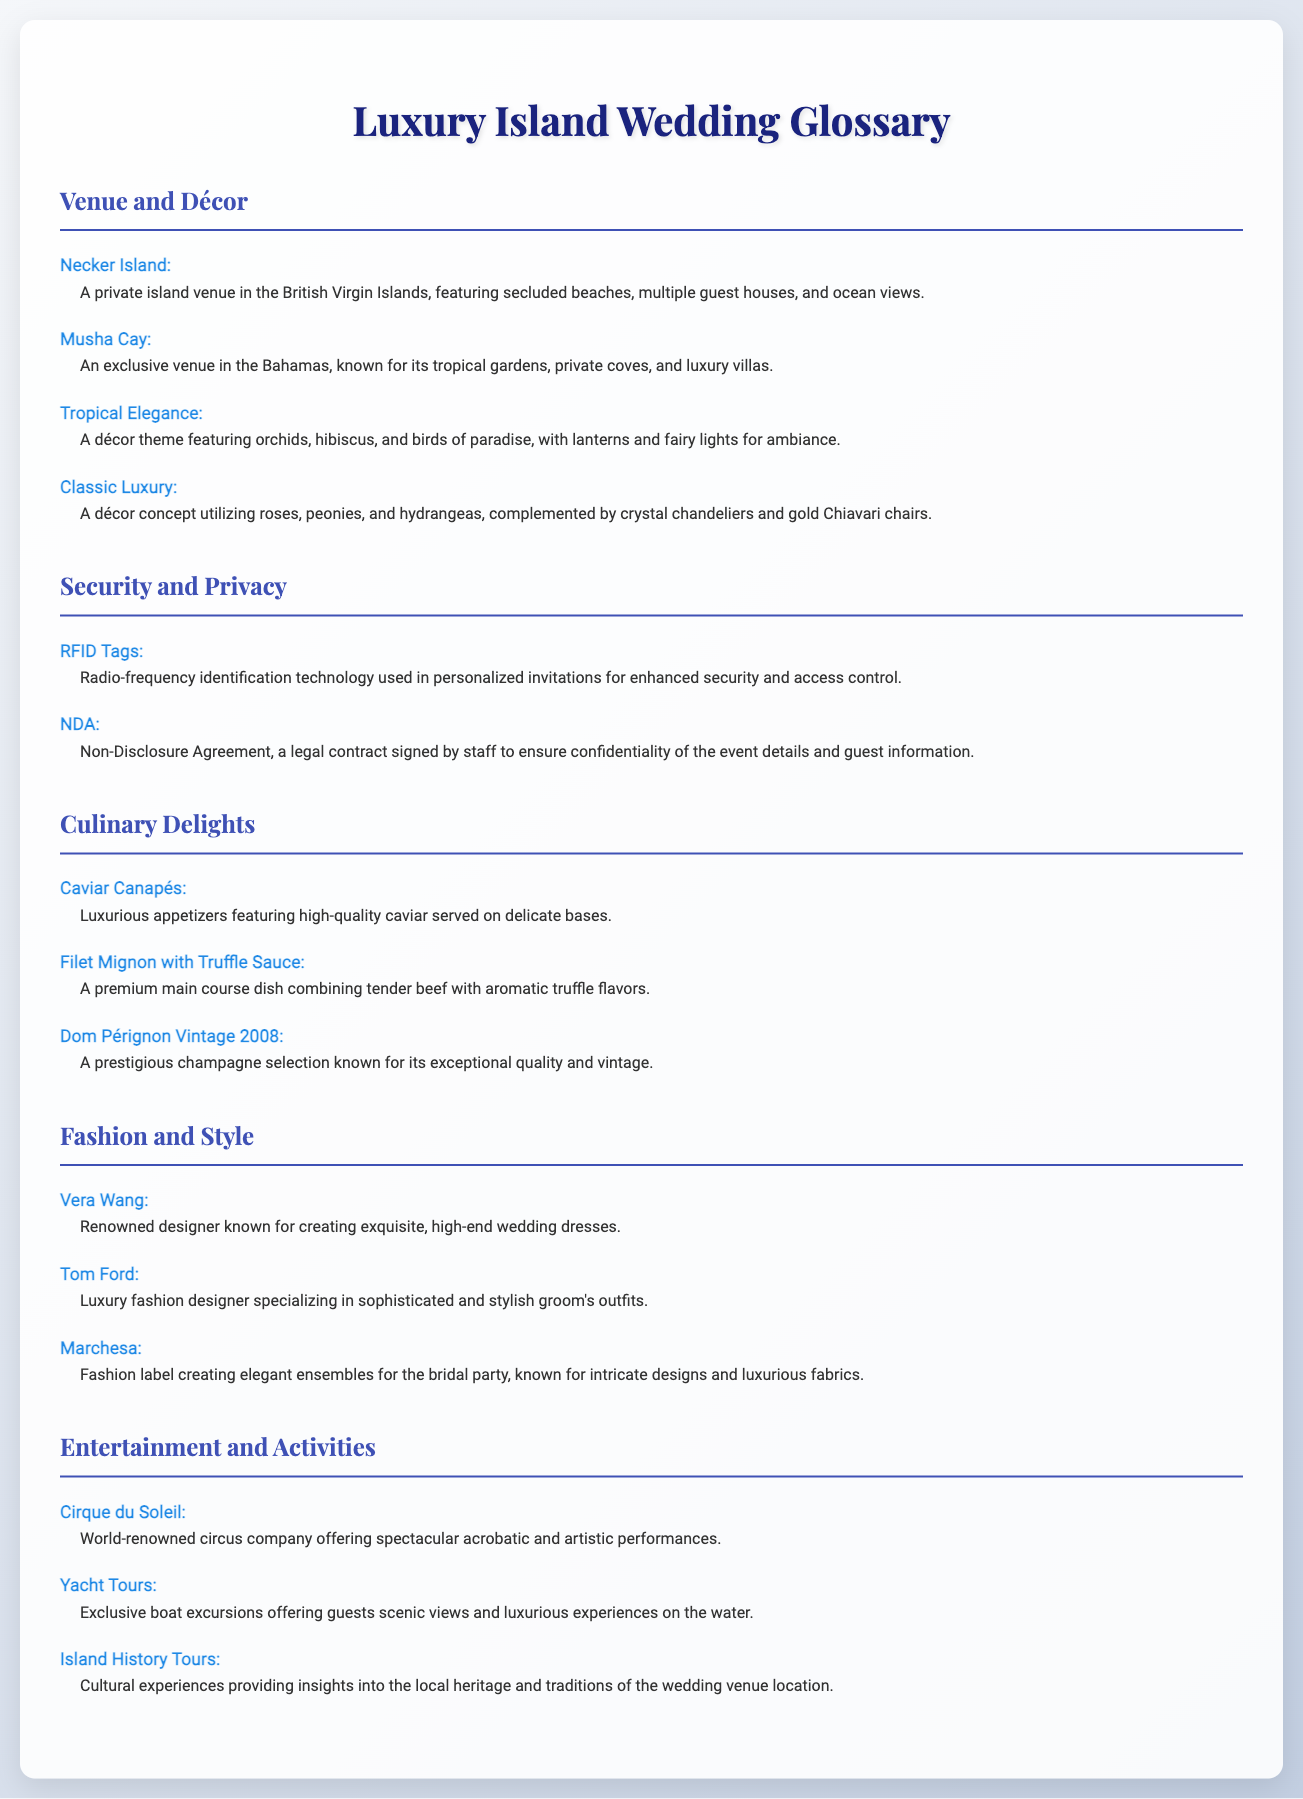What is the name of a private island venue in the British Virgin Islands? Necker Island is mentioned as a private island venue in the British Virgin Islands in the document.
Answer: Necker Island What décor theme features orchids and lanterns? The document describes the "Tropical Elegance" décor theme, which includes orchids, hibiscus, and lanterns.
Answer: Tropical Elegance Which legal contract ensures confidentiality of event details? The document states that an NDA (Non-Disclosure Agreement) is a legal contract for confidentiality.
Answer: NDA What is a luxurious appetizer mentioned in the culinary section? The document lists "Caviar Canapés" as a luxurious appetizer option.
Answer: Caviar Canapés Which designer is known for creating high-end wedding dresses? Vera Wang is identified in the document as a renowned designer for wedding dresses.
Answer: Vera Wang What is the name of the world-renowned circus company? The document mentions "Cirque du Soleil" as the name of the circus company offering performances.
Answer: Cirque du Soleil What type of tours provide insights into local heritage? The document refers to "Island History Tours" as cultural experiences offering insights into local heritage.
Answer: Island History Tours How are security measures enhanced through invitations? The document indicates that RFID Tags are used in personalized invitations for enhanced security.
Answer: RFID Tags What premium champagne is listed in the gourmet options? The document mentions "Dom Pérignon Vintage 2008" as a prestigious champagne selection.
Answer: Dom Pérignon Vintage 2008 